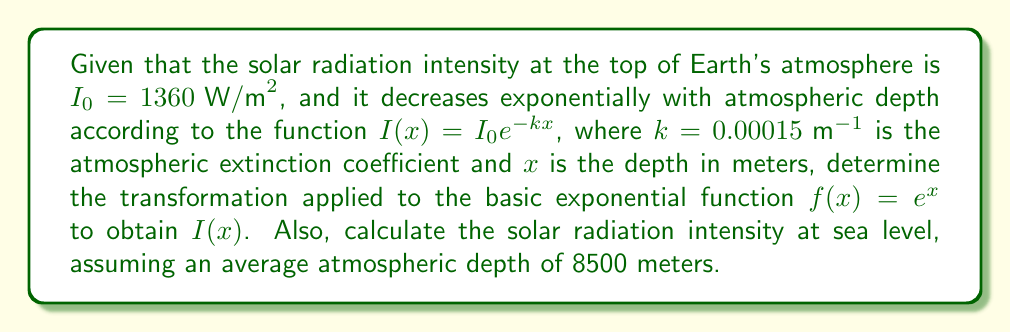Show me your answer to this math problem. 1. First, let's identify the basic exponential function: $f(x) = e^x$

2. Now, let's compare this to our given function: $I(x) = I_0 e^{-kx}$

3. To transform $f(x)$ into $I(x)$, we need to apply the following steps:
   a. Multiply the exponent by $-k$: $e^{-kx}$
   b. Multiply the entire function by $I_0$: $I_0 e^{-kx}$

4. Therefore, the transformation applied to $f(x)$ is:
   - Horizontal stretch by a factor of $\frac{1}{k}$
   - Reflection over the y-axis
   - Vertical stretch by a factor of $I_0$

5. To calculate the solar radiation intensity at sea level:
   - Use $x = 8500 \text{ m}$ (average atmospheric depth)
   - $I(8500) = 1360 \cdot e^{-0.00015 \cdot 8500}$
   - $I(8500) = 1360 \cdot e^{-1.275}$
   - $I(8500) = 1360 \cdot 0.2793$
   - $I(8500) \approx 379.8 \text{ W/m}^2$
Answer: Transformation: $h(x) = 1360 \cdot f(-0.00015x)$; Sea level intensity: $379.8 \text{ W/m}^2$ 